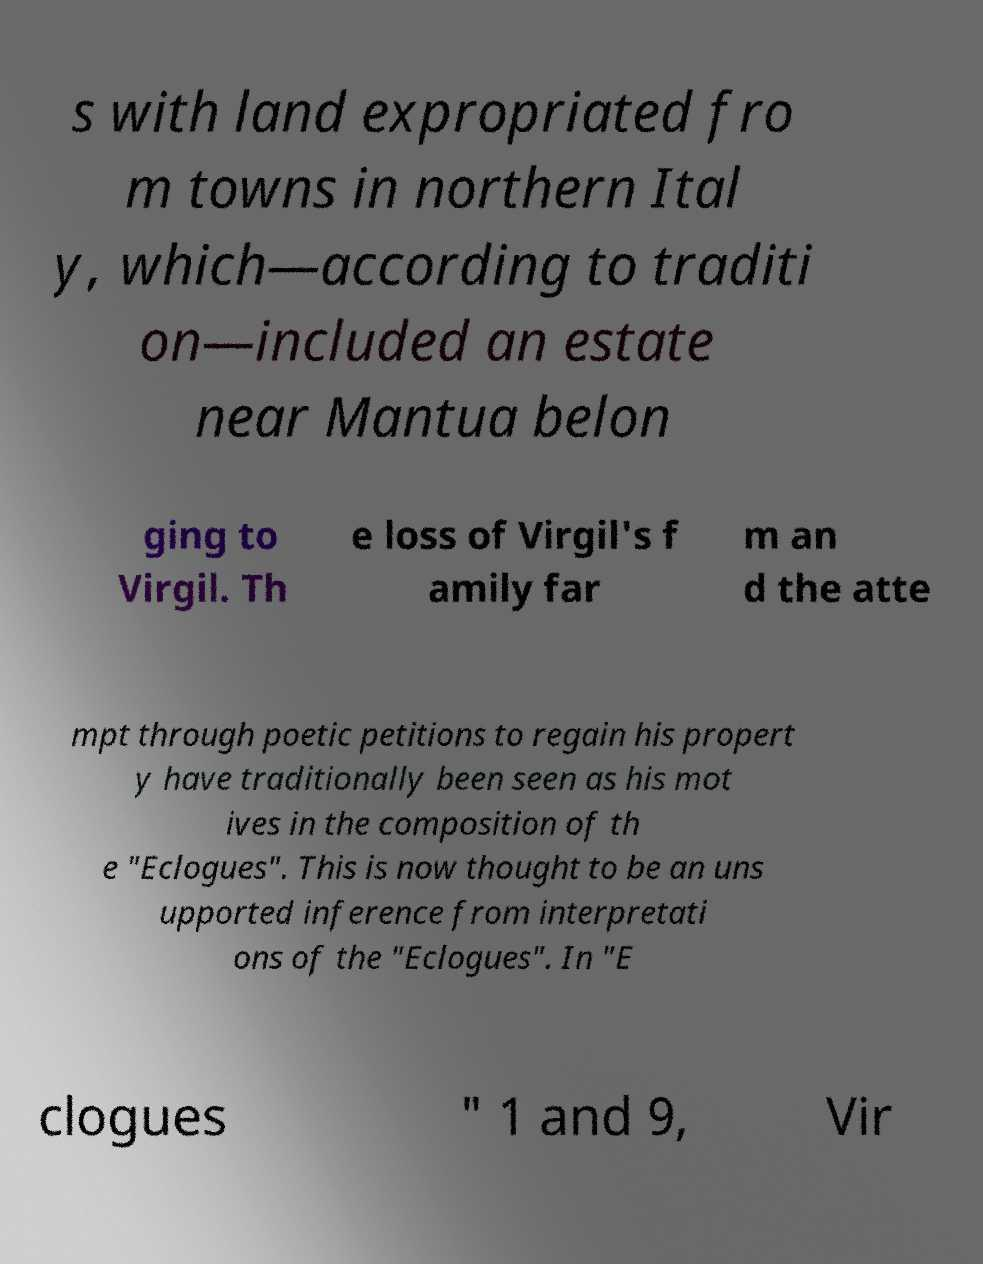What messages or text are displayed in this image? I need them in a readable, typed format. s with land expropriated fro m towns in northern Ital y, which—according to traditi on—included an estate near Mantua belon ging to Virgil. Th e loss of Virgil's f amily far m an d the atte mpt through poetic petitions to regain his propert y have traditionally been seen as his mot ives in the composition of th e "Eclogues". This is now thought to be an uns upported inference from interpretati ons of the "Eclogues". In "E clogues " 1 and 9, Vir 